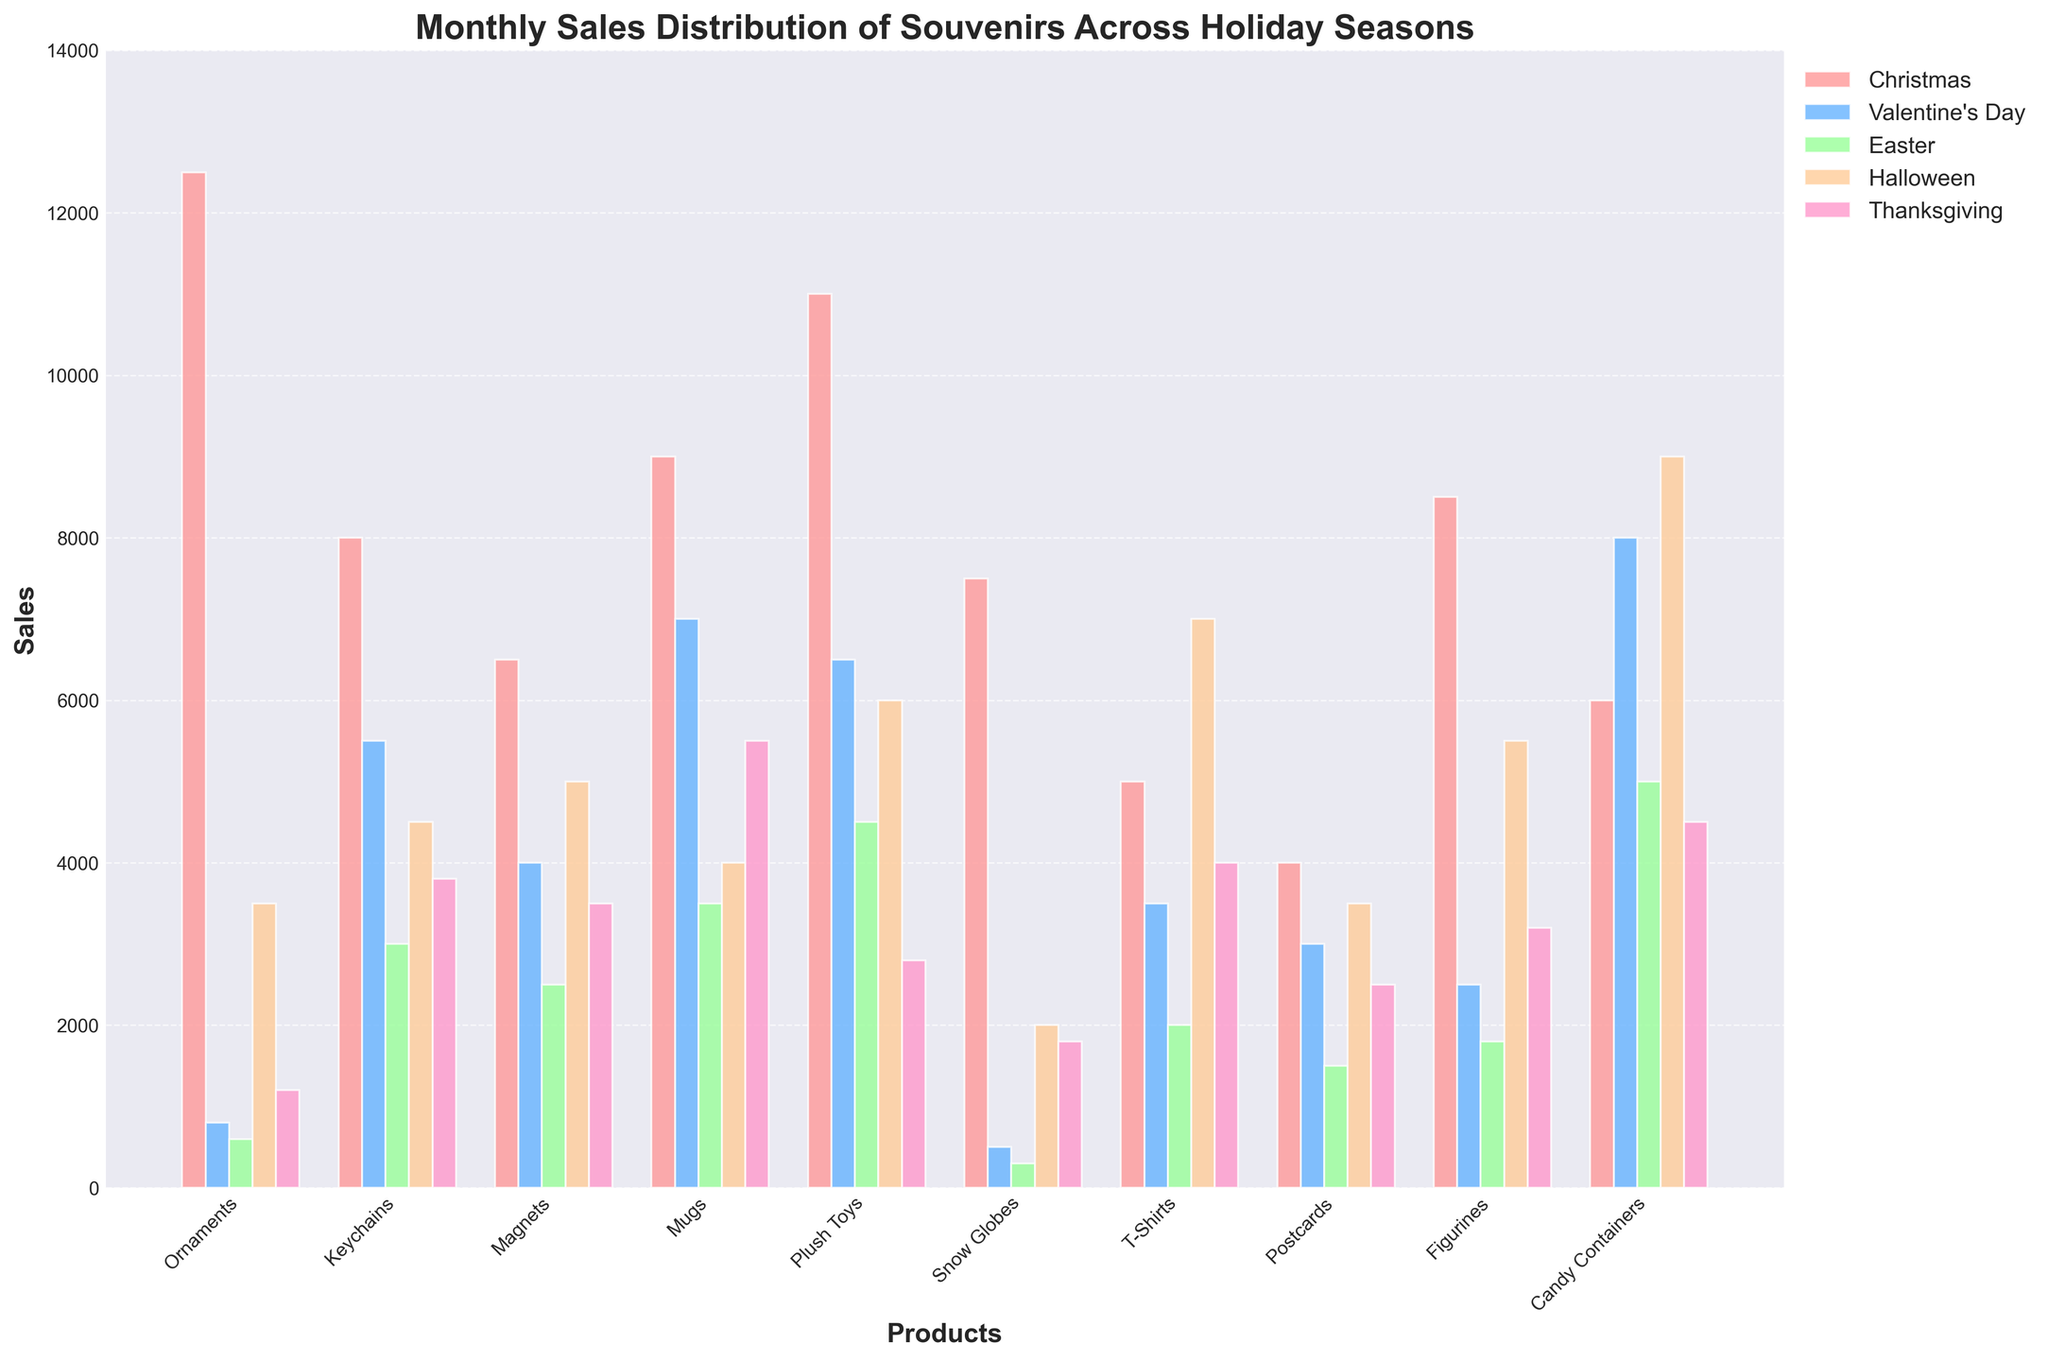Which product had the highest sales during Christmas? Look at the bars corresponding to Christmas and identify the tallest one. Ornaments has the tallest bar.
Answer: Ornaments Which holiday saw the highest sales of Candy Containers? Compare all sales bars of Candy Containers across holidays. The tallest bar is during Halloween.
Answer: Halloween What is the total sales of Mugs during Christmas and Valentine's Day combined? Look at the sales for Mugs during Christmas and Valentine's Day, then add them together: 9000 (Christmas) + 7000 (Valentine's Day) = 16000.
Answer: 16000 Which holiday had the highest sales for Keychains? Compare the heights of the bars corresponding to Keychains across all holidays. The tallest bar for Keychains is during Valentine's Day.
Answer: Valentine's Day How do sales of Plush Toys during Halloween compare to sales of Magnets during the same holiday? Look at the bars for Plush Toys and Magnets during Halloween. The bar for Plush Toys is taller than the bar for Magnets.
Answer: Plush Toys have higher sales Among all the holidays, which holiday has the least sales for Snow Globes? Identify the smallest bar corresponding to Snow Globes across all holidays. The smallest bar is during Easter.
Answer: Easter What is the average sales of Postcards during Thanksgiving, Christmas, and Easter? Sum the sales of Postcards during these holidays and divide by the number of these holidays: (2500 + 4000 + 1500) / 3 = 2666.67.
Answer: 2666.67 Is the sales of T-Shirts during Halloween greater than that during Thanksgiving? Compare the height of bars for T-Shirts during Halloween and Thanksgiving. The bar for Halloween is taller than that for Thanksgiving.
Answer: Yes By how much do the sales of Figurines during Christmas exceed the sales during Easter? Subtract the sales of Figurines during Easter from sales during Christmas: 8500 (Christmas) - 1800 (Easter) = 6700.
Answer: 6700 